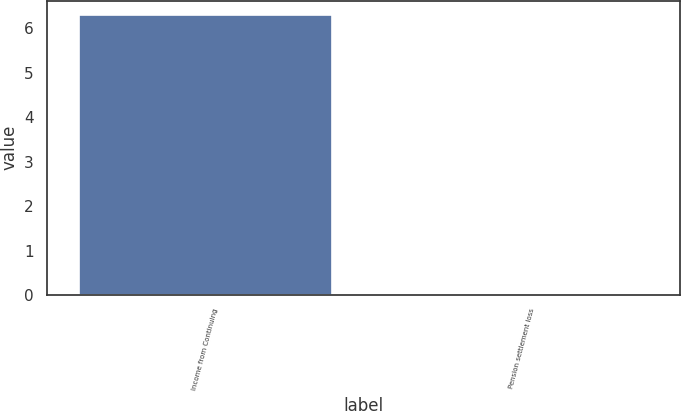Convert chart to OTSL. <chart><loc_0><loc_0><loc_500><loc_500><bar_chart><fcel>Income from Continuing<fcel>Pension settlement loss<nl><fcel>6.31<fcel>0.03<nl></chart> 